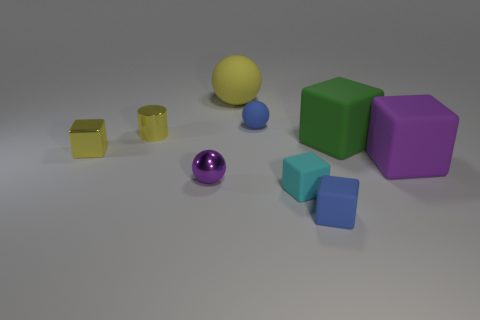Can you create a story involving the objects in the picture? Certainly! In a quiet room filled with soft light, the colorful geometric objects gathered to discuss their dreams. The yellow cylinder, known for its boldness, wished to become a beacon in a lighthouse. The purple sphere, reflective and wise, dreamt of rolling across galaxies as a miniature planet. The cubes, reliable and steady, aspired to be essential building blocks of grand structures, each appreciating their simple yet strong design. Together, they shared a vision of a world where every shape, no matter how small or bright, could serve a purpose far greater than imagined within their little gathering space. 